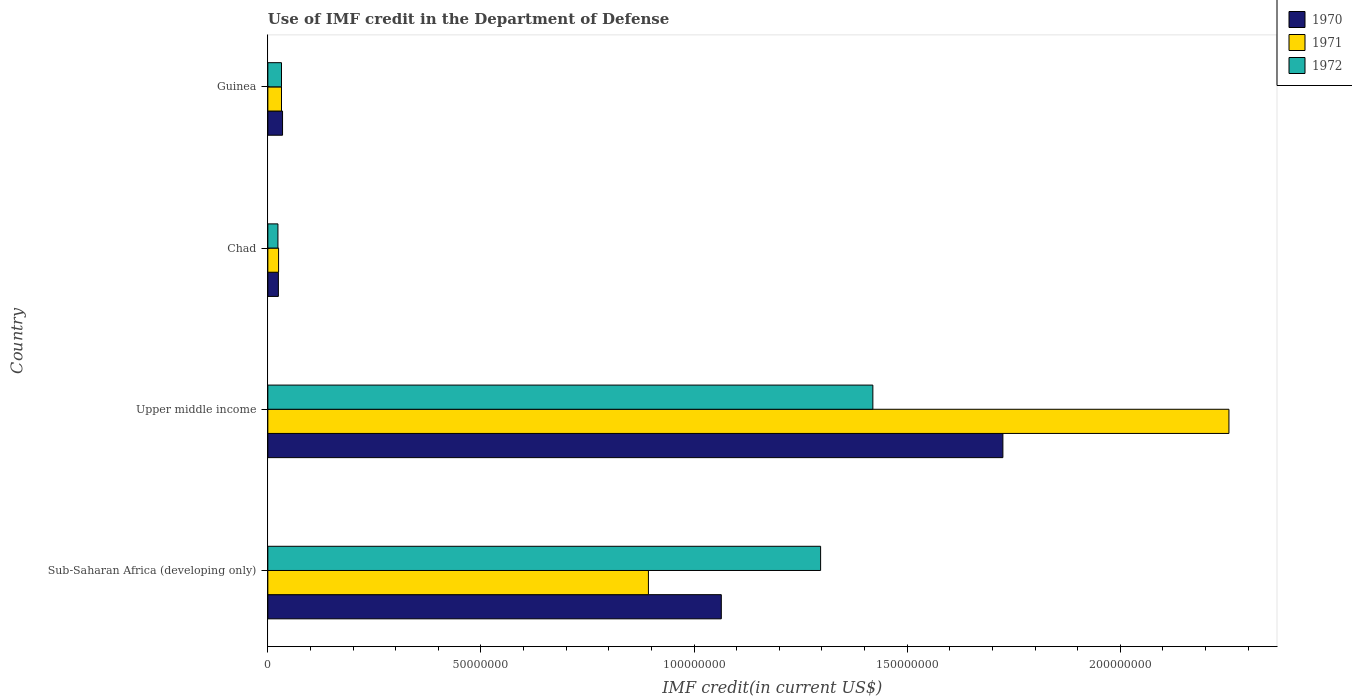How many different coloured bars are there?
Provide a short and direct response. 3. Are the number of bars per tick equal to the number of legend labels?
Make the answer very short. Yes. What is the label of the 3rd group of bars from the top?
Ensure brevity in your answer.  Upper middle income. In how many cases, is the number of bars for a given country not equal to the number of legend labels?
Your response must be concise. 0. What is the IMF credit in the Department of Defense in 1971 in Guinea?
Provide a short and direct response. 3.20e+06. Across all countries, what is the maximum IMF credit in the Department of Defense in 1970?
Your answer should be very brief. 1.72e+08. Across all countries, what is the minimum IMF credit in the Department of Defense in 1971?
Provide a short and direct response. 2.52e+06. In which country was the IMF credit in the Department of Defense in 1970 maximum?
Offer a terse response. Upper middle income. In which country was the IMF credit in the Department of Defense in 1971 minimum?
Offer a terse response. Chad. What is the total IMF credit in the Department of Defense in 1971 in the graph?
Provide a short and direct response. 3.20e+08. What is the difference between the IMF credit in the Department of Defense in 1970 in Chad and that in Guinea?
Provide a short and direct response. -9.80e+05. What is the difference between the IMF credit in the Department of Defense in 1970 in Upper middle income and the IMF credit in the Department of Defense in 1971 in Sub-Saharan Africa (developing only)?
Make the answer very short. 8.32e+07. What is the average IMF credit in the Department of Defense in 1970 per country?
Ensure brevity in your answer.  7.12e+07. What is the difference between the IMF credit in the Department of Defense in 1972 and IMF credit in the Department of Defense in 1970 in Sub-Saharan Africa (developing only)?
Offer a terse response. 2.33e+07. In how many countries, is the IMF credit in the Department of Defense in 1970 greater than 180000000 US$?
Provide a short and direct response. 0. What is the ratio of the IMF credit in the Department of Defense in 1971 in Sub-Saharan Africa (developing only) to that in Upper middle income?
Offer a very short reply. 0.4. Is the IMF credit in the Department of Defense in 1972 in Chad less than that in Upper middle income?
Provide a short and direct response. Yes. Is the difference between the IMF credit in the Department of Defense in 1972 in Sub-Saharan Africa (developing only) and Upper middle income greater than the difference between the IMF credit in the Department of Defense in 1970 in Sub-Saharan Africa (developing only) and Upper middle income?
Your response must be concise. Yes. What is the difference between the highest and the second highest IMF credit in the Department of Defense in 1971?
Make the answer very short. 1.36e+08. What is the difference between the highest and the lowest IMF credit in the Department of Defense in 1971?
Your answer should be very brief. 2.23e+08. In how many countries, is the IMF credit in the Department of Defense in 1970 greater than the average IMF credit in the Department of Defense in 1970 taken over all countries?
Give a very brief answer. 2. Is the sum of the IMF credit in the Department of Defense in 1970 in Guinea and Upper middle income greater than the maximum IMF credit in the Department of Defense in 1972 across all countries?
Ensure brevity in your answer.  Yes. What does the 1st bar from the top in Guinea represents?
Provide a short and direct response. 1972. Is it the case that in every country, the sum of the IMF credit in the Department of Defense in 1971 and IMF credit in the Department of Defense in 1972 is greater than the IMF credit in the Department of Defense in 1970?
Offer a terse response. Yes. Are the values on the major ticks of X-axis written in scientific E-notation?
Make the answer very short. No. Does the graph contain any zero values?
Your answer should be very brief. No. How many legend labels are there?
Your answer should be very brief. 3. How are the legend labels stacked?
Your response must be concise. Vertical. What is the title of the graph?
Provide a short and direct response. Use of IMF credit in the Department of Defense. What is the label or title of the X-axis?
Provide a succinct answer. IMF credit(in current US$). What is the IMF credit(in current US$) of 1970 in Sub-Saharan Africa (developing only)?
Give a very brief answer. 1.06e+08. What is the IMF credit(in current US$) in 1971 in Sub-Saharan Africa (developing only)?
Your response must be concise. 8.93e+07. What is the IMF credit(in current US$) of 1972 in Sub-Saharan Africa (developing only)?
Keep it short and to the point. 1.30e+08. What is the IMF credit(in current US$) in 1970 in Upper middle income?
Offer a terse response. 1.72e+08. What is the IMF credit(in current US$) of 1971 in Upper middle income?
Give a very brief answer. 2.25e+08. What is the IMF credit(in current US$) of 1972 in Upper middle income?
Provide a succinct answer. 1.42e+08. What is the IMF credit(in current US$) in 1970 in Chad?
Your response must be concise. 2.47e+06. What is the IMF credit(in current US$) in 1971 in Chad?
Offer a terse response. 2.52e+06. What is the IMF credit(in current US$) in 1972 in Chad?
Make the answer very short. 2.37e+06. What is the IMF credit(in current US$) of 1970 in Guinea?
Ensure brevity in your answer.  3.45e+06. What is the IMF credit(in current US$) of 1971 in Guinea?
Keep it short and to the point. 3.20e+06. What is the IMF credit(in current US$) of 1972 in Guinea?
Keep it short and to the point. 3.20e+06. Across all countries, what is the maximum IMF credit(in current US$) in 1970?
Your response must be concise. 1.72e+08. Across all countries, what is the maximum IMF credit(in current US$) of 1971?
Your answer should be compact. 2.25e+08. Across all countries, what is the maximum IMF credit(in current US$) in 1972?
Ensure brevity in your answer.  1.42e+08. Across all countries, what is the minimum IMF credit(in current US$) in 1970?
Offer a very short reply. 2.47e+06. Across all countries, what is the minimum IMF credit(in current US$) of 1971?
Offer a terse response. 2.52e+06. Across all countries, what is the minimum IMF credit(in current US$) of 1972?
Provide a short and direct response. 2.37e+06. What is the total IMF credit(in current US$) in 1970 in the graph?
Provide a succinct answer. 2.85e+08. What is the total IMF credit(in current US$) in 1971 in the graph?
Your response must be concise. 3.20e+08. What is the total IMF credit(in current US$) in 1972 in the graph?
Offer a terse response. 2.77e+08. What is the difference between the IMF credit(in current US$) of 1970 in Sub-Saharan Africa (developing only) and that in Upper middle income?
Offer a very short reply. -6.61e+07. What is the difference between the IMF credit(in current US$) of 1971 in Sub-Saharan Africa (developing only) and that in Upper middle income?
Your response must be concise. -1.36e+08. What is the difference between the IMF credit(in current US$) in 1972 in Sub-Saharan Africa (developing only) and that in Upper middle income?
Provide a succinct answer. -1.23e+07. What is the difference between the IMF credit(in current US$) in 1970 in Sub-Saharan Africa (developing only) and that in Chad?
Keep it short and to the point. 1.04e+08. What is the difference between the IMF credit(in current US$) in 1971 in Sub-Saharan Africa (developing only) and that in Chad?
Your answer should be compact. 8.68e+07. What is the difference between the IMF credit(in current US$) in 1972 in Sub-Saharan Africa (developing only) and that in Chad?
Your answer should be compact. 1.27e+08. What is the difference between the IMF credit(in current US$) in 1970 in Sub-Saharan Africa (developing only) and that in Guinea?
Provide a succinct answer. 1.03e+08. What is the difference between the IMF credit(in current US$) of 1971 in Sub-Saharan Africa (developing only) and that in Guinea?
Provide a succinct answer. 8.61e+07. What is the difference between the IMF credit(in current US$) of 1972 in Sub-Saharan Africa (developing only) and that in Guinea?
Provide a short and direct response. 1.26e+08. What is the difference between the IMF credit(in current US$) of 1970 in Upper middle income and that in Chad?
Provide a short and direct response. 1.70e+08. What is the difference between the IMF credit(in current US$) in 1971 in Upper middle income and that in Chad?
Keep it short and to the point. 2.23e+08. What is the difference between the IMF credit(in current US$) of 1972 in Upper middle income and that in Chad?
Make the answer very short. 1.40e+08. What is the difference between the IMF credit(in current US$) in 1970 in Upper middle income and that in Guinea?
Ensure brevity in your answer.  1.69e+08. What is the difference between the IMF credit(in current US$) of 1971 in Upper middle income and that in Guinea?
Make the answer very short. 2.22e+08. What is the difference between the IMF credit(in current US$) of 1972 in Upper middle income and that in Guinea?
Ensure brevity in your answer.  1.39e+08. What is the difference between the IMF credit(in current US$) of 1970 in Chad and that in Guinea?
Your answer should be very brief. -9.80e+05. What is the difference between the IMF credit(in current US$) in 1971 in Chad and that in Guinea?
Your answer should be very brief. -6.84e+05. What is the difference between the IMF credit(in current US$) of 1972 in Chad and that in Guinea?
Provide a short and direct response. -8.36e+05. What is the difference between the IMF credit(in current US$) in 1970 in Sub-Saharan Africa (developing only) and the IMF credit(in current US$) in 1971 in Upper middle income?
Give a very brief answer. -1.19e+08. What is the difference between the IMF credit(in current US$) in 1970 in Sub-Saharan Africa (developing only) and the IMF credit(in current US$) in 1972 in Upper middle income?
Make the answer very short. -3.56e+07. What is the difference between the IMF credit(in current US$) of 1971 in Sub-Saharan Africa (developing only) and the IMF credit(in current US$) of 1972 in Upper middle income?
Your response must be concise. -5.27e+07. What is the difference between the IMF credit(in current US$) in 1970 in Sub-Saharan Africa (developing only) and the IMF credit(in current US$) in 1971 in Chad?
Provide a succinct answer. 1.04e+08. What is the difference between the IMF credit(in current US$) of 1970 in Sub-Saharan Africa (developing only) and the IMF credit(in current US$) of 1972 in Chad?
Ensure brevity in your answer.  1.04e+08. What is the difference between the IMF credit(in current US$) in 1971 in Sub-Saharan Africa (developing only) and the IMF credit(in current US$) in 1972 in Chad?
Offer a terse response. 8.69e+07. What is the difference between the IMF credit(in current US$) in 1970 in Sub-Saharan Africa (developing only) and the IMF credit(in current US$) in 1971 in Guinea?
Offer a terse response. 1.03e+08. What is the difference between the IMF credit(in current US$) in 1970 in Sub-Saharan Africa (developing only) and the IMF credit(in current US$) in 1972 in Guinea?
Keep it short and to the point. 1.03e+08. What is the difference between the IMF credit(in current US$) in 1971 in Sub-Saharan Africa (developing only) and the IMF credit(in current US$) in 1972 in Guinea?
Keep it short and to the point. 8.61e+07. What is the difference between the IMF credit(in current US$) in 1970 in Upper middle income and the IMF credit(in current US$) in 1971 in Chad?
Make the answer very short. 1.70e+08. What is the difference between the IMF credit(in current US$) in 1970 in Upper middle income and the IMF credit(in current US$) in 1972 in Chad?
Provide a succinct answer. 1.70e+08. What is the difference between the IMF credit(in current US$) of 1971 in Upper middle income and the IMF credit(in current US$) of 1972 in Chad?
Your response must be concise. 2.23e+08. What is the difference between the IMF credit(in current US$) in 1970 in Upper middle income and the IMF credit(in current US$) in 1971 in Guinea?
Your answer should be very brief. 1.69e+08. What is the difference between the IMF credit(in current US$) of 1970 in Upper middle income and the IMF credit(in current US$) of 1972 in Guinea?
Offer a terse response. 1.69e+08. What is the difference between the IMF credit(in current US$) of 1971 in Upper middle income and the IMF credit(in current US$) of 1972 in Guinea?
Your response must be concise. 2.22e+08. What is the difference between the IMF credit(in current US$) of 1970 in Chad and the IMF credit(in current US$) of 1971 in Guinea?
Provide a succinct answer. -7.33e+05. What is the difference between the IMF credit(in current US$) in 1970 in Chad and the IMF credit(in current US$) in 1972 in Guinea?
Give a very brief answer. -7.33e+05. What is the difference between the IMF credit(in current US$) of 1971 in Chad and the IMF credit(in current US$) of 1972 in Guinea?
Make the answer very short. -6.84e+05. What is the average IMF credit(in current US$) in 1970 per country?
Your response must be concise. 7.12e+07. What is the average IMF credit(in current US$) of 1971 per country?
Your answer should be very brief. 8.01e+07. What is the average IMF credit(in current US$) of 1972 per country?
Offer a terse response. 6.93e+07. What is the difference between the IMF credit(in current US$) of 1970 and IMF credit(in current US$) of 1971 in Sub-Saharan Africa (developing only)?
Provide a short and direct response. 1.71e+07. What is the difference between the IMF credit(in current US$) in 1970 and IMF credit(in current US$) in 1972 in Sub-Saharan Africa (developing only)?
Provide a succinct answer. -2.33e+07. What is the difference between the IMF credit(in current US$) of 1971 and IMF credit(in current US$) of 1972 in Sub-Saharan Africa (developing only)?
Your answer should be very brief. -4.04e+07. What is the difference between the IMF credit(in current US$) in 1970 and IMF credit(in current US$) in 1971 in Upper middle income?
Offer a very short reply. -5.30e+07. What is the difference between the IMF credit(in current US$) in 1970 and IMF credit(in current US$) in 1972 in Upper middle income?
Your answer should be compact. 3.05e+07. What is the difference between the IMF credit(in current US$) of 1971 and IMF credit(in current US$) of 1972 in Upper middle income?
Ensure brevity in your answer.  8.35e+07. What is the difference between the IMF credit(in current US$) in 1970 and IMF credit(in current US$) in 1971 in Chad?
Give a very brief answer. -4.90e+04. What is the difference between the IMF credit(in current US$) of 1970 and IMF credit(in current US$) of 1972 in Chad?
Your answer should be very brief. 1.03e+05. What is the difference between the IMF credit(in current US$) of 1971 and IMF credit(in current US$) of 1972 in Chad?
Give a very brief answer. 1.52e+05. What is the difference between the IMF credit(in current US$) in 1970 and IMF credit(in current US$) in 1971 in Guinea?
Your answer should be very brief. 2.47e+05. What is the difference between the IMF credit(in current US$) in 1970 and IMF credit(in current US$) in 1972 in Guinea?
Give a very brief answer. 2.47e+05. What is the difference between the IMF credit(in current US$) of 1971 and IMF credit(in current US$) of 1972 in Guinea?
Provide a short and direct response. 0. What is the ratio of the IMF credit(in current US$) of 1970 in Sub-Saharan Africa (developing only) to that in Upper middle income?
Make the answer very short. 0.62. What is the ratio of the IMF credit(in current US$) of 1971 in Sub-Saharan Africa (developing only) to that in Upper middle income?
Keep it short and to the point. 0.4. What is the ratio of the IMF credit(in current US$) in 1972 in Sub-Saharan Africa (developing only) to that in Upper middle income?
Your response must be concise. 0.91. What is the ratio of the IMF credit(in current US$) of 1970 in Sub-Saharan Africa (developing only) to that in Chad?
Your answer should be very brief. 43.07. What is the ratio of the IMF credit(in current US$) of 1971 in Sub-Saharan Africa (developing only) to that in Chad?
Your answer should be compact. 35.45. What is the ratio of the IMF credit(in current US$) of 1972 in Sub-Saharan Africa (developing only) to that in Chad?
Your answer should be compact. 54.79. What is the ratio of the IMF credit(in current US$) of 1970 in Sub-Saharan Africa (developing only) to that in Guinea?
Ensure brevity in your answer.  30.84. What is the ratio of the IMF credit(in current US$) of 1971 in Sub-Saharan Africa (developing only) to that in Guinea?
Your answer should be compact. 27.88. What is the ratio of the IMF credit(in current US$) of 1972 in Sub-Saharan Africa (developing only) to that in Guinea?
Your response must be concise. 40.49. What is the ratio of the IMF credit(in current US$) in 1970 in Upper middle income to that in Chad?
Your response must be concise. 69.82. What is the ratio of the IMF credit(in current US$) of 1971 in Upper middle income to that in Chad?
Offer a terse response. 89.51. What is the ratio of the IMF credit(in current US$) in 1972 in Upper middle income to that in Chad?
Your answer should be very brief. 59.97. What is the ratio of the IMF credit(in current US$) of 1970 in Upper middle income to that in Guinea?
Offer a terse response. 49.99. What is the ratio of the IMF credit(in current US$) of 1971 in Upper middle income to that in Guinea?
Offer a terse response. 70.4. What is the ratio of the IMF credit(in current US$) of 1972 in Upper middle income to that in Guinea?
Offer a terse response. 44.32. What is the ratio of the IMF credit(in current US$) in 1970 in Chad to that in Guinea?
Your answer should be very brief. 0.72. What is the ratio of the IMF credit(in current US$) of 1971 in Chad to that in Guinea?
Your answer should be very brief. 0.79. What is the ratio of the IMF credit(in current US$) of 1972 in Chad to that in Guinea?
Ensure brevity in your answer.  0.74. What is the difference between the highest and the second highest IMF credit(in current US$) of 1970?
Give a very brief answer. 6.61e+07. What is the difference between the highest and the second highest IMF credit(in current US$) of 1971?
Offer a terse response. 1.36e+08. What is the difference between the highest and the second highest IMF credit(in current US$) in 1972?
Your answer should be very brief. 1.23e+07. What is the difference between the highest and the lowest IMF credit(in current US$) in 1970?
Provide a short and direct response. 1.70e+08. What is the difference between the highest and the lowest IMF credit(in current US$) of 1971?
Your answer should be very brief. 2.23e+08. What is the difference between the highest and the lowest IMF credit(in current US$) of 1972?
Give a very brief answer. 1.40e+08. 